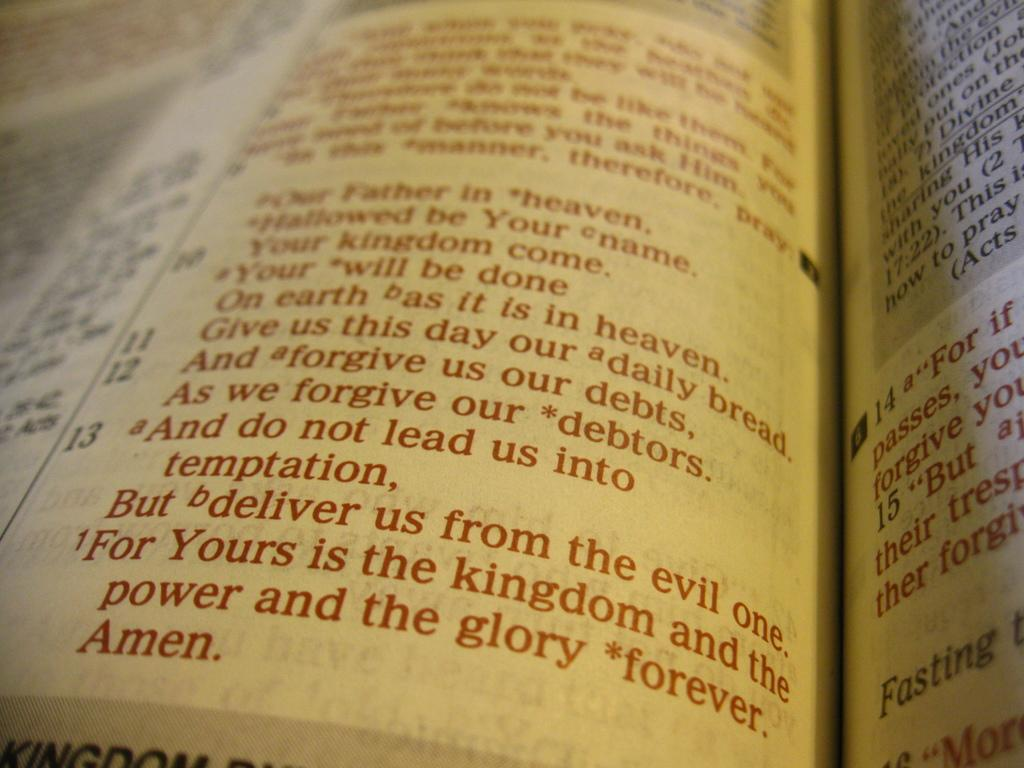<image>
Render a clear and concise summary of the photo. A white page with red letters with the last line that reads, "Amen." 